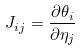Convert formula to latex. <formula><loc_0><loc_0><loc_500><loc_500>J _ { i j } = \frac { \partial \theta _ { i } } { \partial \eta _ { j } }</formula> 